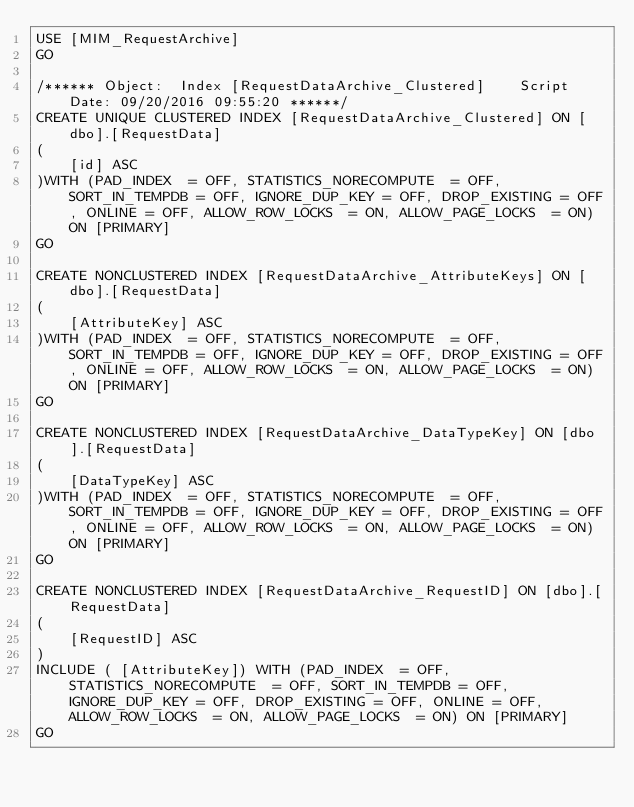Convert code to text. <code><loc_0><loc_0><loc_500><loc_500><_SQL_>USE [MIM_RequestArchive]
GO

/****** Object:  Index [RequestDataArchive_Clustered]    Script Date: 09/20/2016 09:55:20 ******/
CREATE UNIQUE CLUSTERED INDEX [RequestDataArchive_Clustered] ON [dbo].[RequestData] 
(
	[id] ASC
)WITH (PAD_INDEX  = OFF, STATISTICS_NORECOMPUTE  = OFF, SORT_IN_TEMPDB = OFF, IGNORE_DUP_KEY = OFF, DROP_EXISTING = OFF, ONLINE = OFF, ALLOW_ROW_LOCKS  = ON, ALLOW_PAGE_LOCKS  = ON) ON [PRIMARY]
GO

CREATE NONCLUSTERED INDEX [RequestDataArchive_AttributeKeys] ON [dbo].[RequestData] 
(
	[AttributeKey] ASC
)WITH (PAD_INDEX  = OFF, STATISTICS_NORECOMPUTE  = OFF, SORT_IN_TEMPDB = OFF, IGNORE_DUP_KEY = OFF, DROP_EXISTING = OFF, ONLINE = OFF, ALLOW_ROW_LOCKS  = ON, ALLOW_PAGE_LOCKS  = ON) ON [PRIMARY]
GO

CREATE NONCLUSTERED INDEX [RequestDataArchive_DataTypeKey] ON [dbo].[RequestData] 
(
	[DataTypeKey] ASC
)WITH (PAD_INDEX  = OFF, STATISTICS_NORECOMPUTE  = OFF, SORT_IN_TEMPDB = OFF, IGNORE_DUP_KEY = OFF, DROP_EXISTING = OFF, ONLINE = OFF, ALLOW_ROW_LOCKS  = ON, ALLOW_PAGE_LOCKS  = ON) ON [PRIMARY]
GO

CREATE NONCLUSTERED INDEX [RequestDataArchive_RequestID] ON [dbo].[RequestData] 
(
	[RequestID] ASC
)
INCLUDE ( [AttributeKey]) WITH (PAD_INDEX  = OFF, STATISTICS_NORECOMPUTE  = OFF, SORT_IN_TEMPDB = OFF, IGNORE_DUP_KEY = OFF, DROP_EXISTING = OFF, ONLINE = OFF, ALLOW_ROW_LOCKS  = ON, ALLOW_PAGE_LOCKS  = ON) ON [PRIMARY]
GO
</code> 